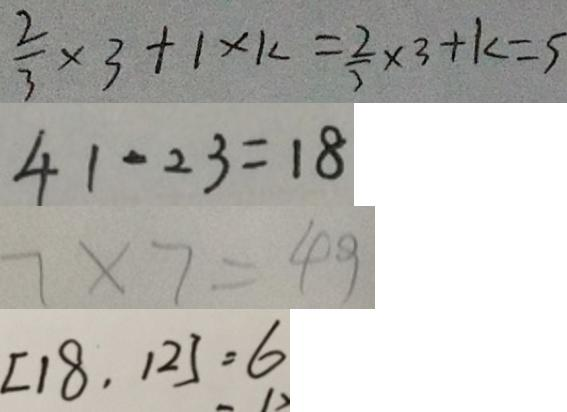<formula> <loc_0><loc_0><loc_500><loc_500>\frac { 2 } { 3 } \times 3 + 1 \times k = \frac { 2 } { 3 } \times 3 + k = 5 
 4 1 - 2 3 = 1 8 
 7 \times 7 = 4 9 
 [ 1 8 , 1 2 ] = 6</formula> 